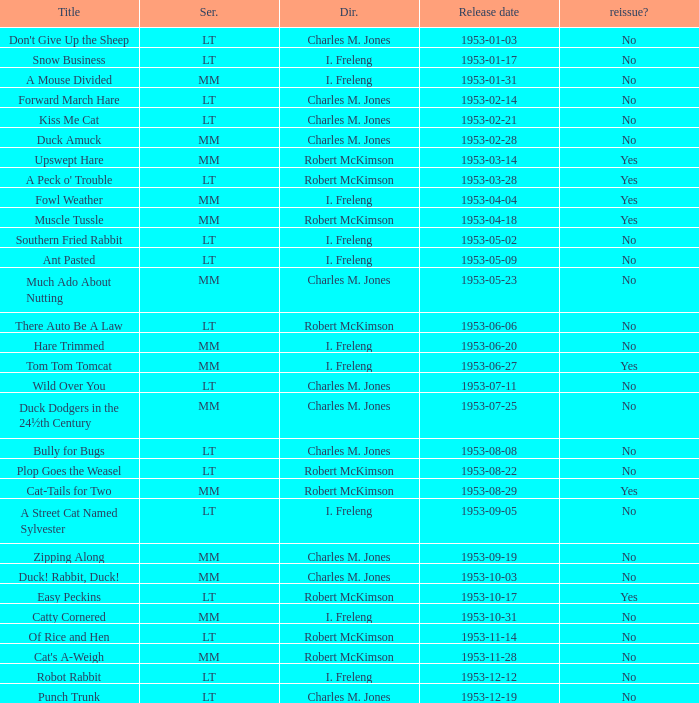Help me parse the entirety of this table. {'header': ['Title', 'Ser.', 'Dir.', 'Release date', 'reissue?'], 'rows': [["Don't Give Up the Sheep", 'LT', 'Charles M. Jones', '1953-01-03', 'No'], ['Snow Business', 'LT', 'I. Freleng', '1953-01-17', 'No'], ['A Mouse Divided', 'MM', 'I. Freleng', '1953-01-31', 'No'], ['Forward March Hare', 'LT', 'Charles M. Jones', '1953-02-14', 'No'], ['Kiss Me Cat', 'LT', 'Charles M. Jones', '1953-02-21', 'No'], ['Duck Amuck', 'MM', 'Charles M. Jones', '1953-02-28', 'No'], ['Upswept Hare', 'MM', 'Robert McKimson', '1953-03-14', 'Yes'], ["A Peck o' Trouble", 'LT', 'Robert McKimson', '1953-03-28', 'Yes'], ['Fowl Weather', 'MM', 'I. Freleng', '1953-04-04', 'Yes'], ['Muscle Tussle', 'MM', 'Robert McKimson', '1953-04-18', 'Yes'], ['Southern Fried Rabbit', 'LT', 'I. Freleng', '1953-05-02', 'No'], ['Ant Pasted', 'LT', 'I. Freleng', '1953-05-09', 'No'], ['Much Ado About Nutting', 'MM', 'Charles M. Jones', '1953-05-23', 'No'], ['There Auto Be A Law', 'LT', 'Robert McKimson', '1953-06-06', 'No'], ['Hare Trimmed', 'MM', 'I. Freleng', '1953-06-20', 'No'], ['Tom Tom Tomcat', 'MM', 'I. Freleng', '1953-06-27', 'Yes'], ['Wild Over You', 'LT', 'Charles M. Jones', '1953-07-11', 'No'], ['Duck Dodgers in the 24½th Century', 'MM', 'Charles M. Jones', '1953-07-25', 'No'], ['Bully for Bugs', 'LT', 'Charles M. Jones', '1953-08-08', 'No'], ['Plop Goes the Weasel', 'LT', 'Robert McKimson', '1953-08-22', 'No'], ['Cat-Tails for Two', 'MM', 'Robert McKimson', '1953-08-29', 'Yes'], ['A Street Cat Named Sylvester', 'LT', 'I. Freleng', '1953-09-05', 'No'], ['Zipping Along', 'MM', 'Charles M. Jones', '1953-09-19', 'No'], ['Duck! Rabbit, Duck!', 'MM', 'Charles M. Jones', '1953-10-03', 'No'], ['Easy Peckins', 'LT', 'Robert McKimson', '1953-10-17', 'Yes'], ['Catty Cornered', 'MM', 'I. Freleng', '1953-10-31', 'No'], ['Of Rice and Hen', 'LT', 'Robert McKimson', '1953-11-14', 'No'], ["Cat's A-Weigh", 'MM', 'Robert McKimson', '1953-11-28', 'No'], ['Robot Rabbit', 'LT', 'I. Freleng', '1953-12-12', 'No'], ['Punch Trunk', 'LT', 'Charles M. Jones', '1953-12-19', 'No']]} What's the title for the release date of 1953-01-31 in the MM series, no reissue, and a director of I. Freleng? A Mouse Divided. 